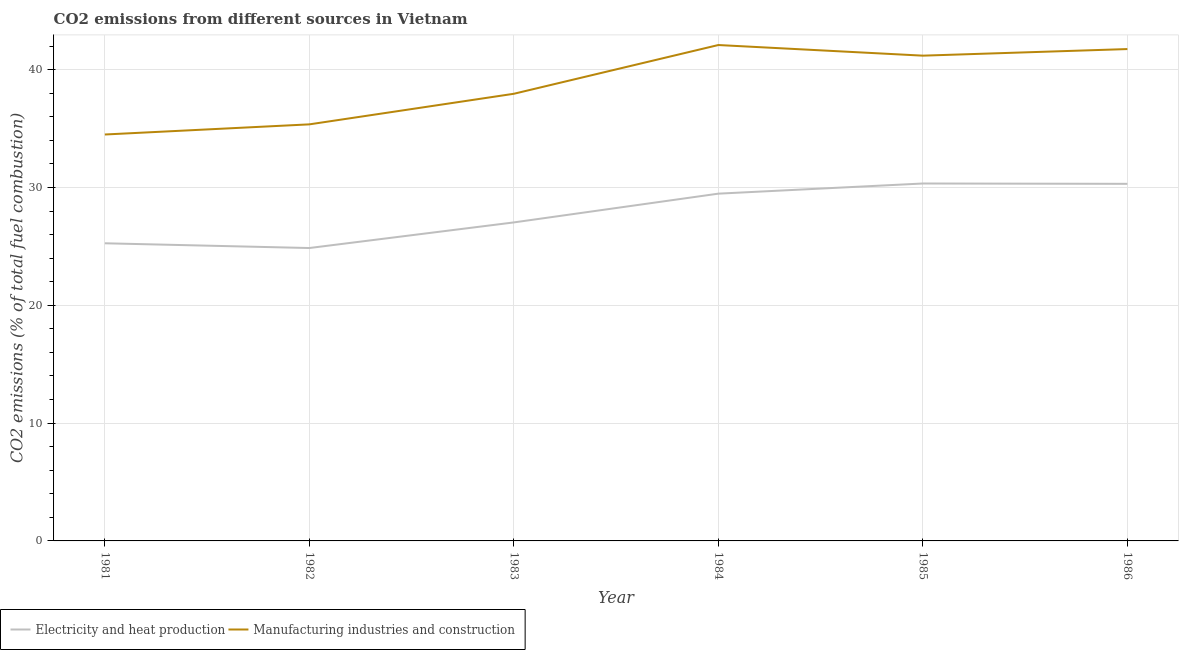How many different coloured lines are there?
Keep it short and to the point. 2. Does the line corresponding to co2 emissions due to manufacturing industries intersect with the line corresponding to co2 emissions due to electricity and heat production?
Keep it short and to the point. No. Is the number of lines equal to the number of legend labels?
Make the answer very short. Yes. What is the co2 emissions due to electricity and heat production in 1985?
Offer a very short reply. 30.34. Across all years, what is the maximum co2 emissions due to electricity and heat production?
Give a very brief answer. 30.34. Across all years, what is the minimum co2 emissions due to manufacturing industries?
Provide a short and direct response. 34.5. In which year was the co2 emissions due to electricity and heat production minimum?
Keep it short and to the point. 1982. What is the total co2 emissions due to electricity and heat production in the graph?
Your response must be concise. 167.29. What is the difference between the co2 emissions due to manufacturing industries in 1985 and that in 1986?
Ensure brevity in your answer.  -0.56. What is the difference between the co2 emissions due to electricity and heat production in 1982 and the co2 emissions due to manufacturing industries in 1981?
Keep it short and to the point. -9.64. What is the average co2 emissions due to manufacturing industries per year?
Give a very brief answer. 38.81. In the year 1986, what is the difference between the co2 emissions due to electricity and heat production and co2 emissions due to manufacturing industries?
Provide a succinct answer. -11.44. What is the ratio of the co2 emissions due to manufacturing industries in 1982 to that in 1985?
Your response must be concise. 0.86. Is the co2 emissions due to electricity and heat production in 1983 less than that in 1986?
Make the answer very short. Yes. Is the difference between the co2 emissions due to manufacturing industries in 1982 and 1985 greater than the difference between the co2 emissions due to electricity and heat production in 1982 and 1985?
Provide a short and direct response. No. What is the difference between the highest and the second highest co2 emissions due to manufacturing industries?
Make the answer very short. 0.34. What is the difference between the highest and the lowest co2 emissions due to electricity and heat production?
Provide a succinct answer. 5.48. In how many years, is the co2 emissions due to manufacturing industries greater than the average co2 emissions due to manufacturing industries taken over all years?
Keep it short and to the point. 3. Is the sum of the co2 emissions due to electricity and heat production in 1982 and 1984 greater than the maximum co2 emissions due to manufacturing industries across all years?
Ensure brevity in your answer.  Yes. Does the co2 emissions due to electricity and heat production monotonically increase over the years?
Make the answer very short. No. How many lines are there?
Make the answer very short. 2. Are the values on the major ticks of Y-axis written in scientific E-notation?
Keep it short and to the point. No. Does the graph contain any zero values?
Offer a terse response. No. What is the title of the graph?
Keep it short and to the point. CO2 emissions from different sources in Vietnam. Does "Depositors" appear as one of the legend labels in the graph?
Make the answer very short. No. What is the label or title of the Y-axis?
Your answer should be very brief. CO2 emissions (% of total fuel combustion). What is the CO2 emissions (% of total fuel combustion) in Electricity and heat production in 1981?
Offer a terse response. 25.26. What is the CO2 emissions (% of total fuel combustion) in Manufacturing industries and construction in 1981?
Ensure brevity in your answer.  34.5. What is the CO2 emissions (% of total fuel combustion) of Electricity and heat production in 1982?
Keep it short and to the point. 24.86. What is the CO2 emissions (% of total fuel combustion) in Manufacturing industries and construction in 1982?
Keep it short and to the point. 35.36. What is the CO2 emissions (% of total fuel combustion) of Electricity and heat production in 1983?
Your answer should be very brief. 27.04. What is the CO2 emissions (% of total fuel combustion) in Manufacturing industries and construction in 1983?
Offer a very short reply. 37.95. What is the CO2 emissions (% of total fuel combustion) of Electricity and heat production in 1984?
Your answer should be compact. 29.48. What is the CO2 emissions (% of total fuel combustion) in Manufacturing industries and construction in 1984?
Your response must be concise. 42.09. What is the CO2 emissions (% of total fuel combustion) of Electricity and heat production in 1985?
Offer a very short reply. 30.34. What is the CO2 emissions (% of total fuel combustion) of Manufacturing industries and construction in 1985?
Provide a succinct answer. 41.19. What is the CO2 emissions (% of total fuel combustion) in Electricity and heat production in 1986?
Offer a very short reply. 30.31. What is the CO2 emissions (% of total fuel combustion) of Manufacturing industries and construction in 1986?
Give a very brief answer. 41.75. Across all years, what is the maximum CO2 emissions (% of total fuel combustion) in Electricity and heat production?
Your response must be concise. 30.34. Across all years, what is the maximum CO2 emissions (% of total fuel combustion) in Manufacturing industries and construction?
Give a very brief answer. 42.09. Across all years, what is the minimum CO2 emissions (% of total fuel combustion) of Electricity and heat production?
Make the answer very short. 24.86. Across all years, what is the minimum CO2 emissions (% of total fuel combustion) of Manufacturing industries and construction?
Your answer should be very brief. 34.5. What is the total CO2 emissions (% of total fuel combustion) in Electricity and heat production in the graph?
Provide a succinct answer. 167.29. What is the total CO2 emissions (% of total fuel combustion) of Manufacturing industries and construction in the graph?
Offer a very short reply. 232.85. What is the difference between the CO2 emissions (% of total fuel combustion) in Electricity and heat production in 1981 and that in 1982?
Offer a very short reply. 0.4. What is the difference between the CO2 emissions (% of total fuel combustion) in Manufacturing industries and construction in 1981 and that in 1982?
Offer a terse response. -0.86. What is the difference between the CO2 emissions (% of total fuel combustion) in Electricity and heat production in 1981 and that in 1983?
Offer a terse response. -1.77. What is the difference between the CO2 emissions (% of total fuel combustion) of Manufacturing industries and construction in 1981 and that in 1983?
Offer a terse response. -3.46. What is the difference between the CO2 emissions (% of total fuel combustion) in Electricity and heat production in 1981 and that in 1984?
Keep it short and to the point. -4.21. What is the difference between the CO2 emissions (% of total fuel combustion) of Manufacturing industries and construction in 1981 and that in 1984?
Ensure brevity in your answer.  -7.59. What is the difference between the CO2 emissions (% of total fuel combustion) of Electricity and heat production in 1981 and that in 1985?
Make the answer very short. -5.07. What is the difference between the CO2 emissions (% of total fuel combustion) of Manufacturing industries and construction in 1981 and that in 1985?
Ensure brevity in your answer.  -6.69. What is the difference between the CO2 emissions (% of total fuel combustion) in Electricity and heat production in 1981 and that in 1986?
Provide a short and direct response. -5.05. What is the difference between the CO2 emissions (% of total fuel combustion) of Manufacturing industries and construction in 1981 and that in 1986?
Your answer should be very brief. -7.25. What is the difference between the CO2 emissions (% of total fuel combustion) in Electricity and heat production in 1982 and that in 1983?
Ensure brevity in your answer.  -2.17. What is the difference between the CO2 emissions (% of total fuel combustion) of Manufacturing industries and construction in 1982 and that in 1983?
Offer a very short reply. -2.6. What is the difference between the CO2 emissions (% of total fuel combustion) of Electricity and heat production in 1982 and that in 1984?
Keep it short and to the point. -4.61. What is the difference between the CO2 emissions (% of total fuel combustion) of Manufacturing industries and construction in 1982 and that in 1984?
Keep it short and to the point. -6.73. What is the difference between the CO2 emissions (% of total fuel combustion) in Electricity and heat production in 1982 and that in 1985?
Make the answer very short. -5.48. What is the difference between the CO2 emissions (% of total fuel combustion) in Manufacturing industries and construction in 1982 and that in 1985?
Your answer should be compact. -5.83. What is the difference between the CO2 emissions (% of total fuel combustion) of Electricity and heat production in 1982 and that in 1986?
Your response must be concise. -5.45. What is the difference between the CO2 emissions (% of total fuel combustion) of Manufacturing industries and construction in 1982 and that in 1986?
Give a very brief answer. -6.39. What is the difference between the CO2 emissions (% of total fuel combustion) of Electricity and heat production in 1983 and that in 1984?
Keep it short and to the point. -2.44. What is the difference between the CO2 emissions (% of total fuel combustion) of Manufacturing industries and construction in 1983 and that in 1984?
Provide a short and direct response. -4.14. What is the difference between the CO2 emissions (% of total fuel combustion) of Electricity and heat production in 1983 and that in 1985?
Your answer should be compact. -3.3. What is the difference between the CO2 emissions (% of total fuel combustion) in Manufacturing industries and construction in 1983 and that in 1985?
Provide a short and direct response. -3.24. What is the difference between the CO2 emissions (% of total fuel combustion) of Electricity and heat production in 1983 and that in 1986?
Make the answer very short. -3.27. What is the difference between the CO2 emissions (% of total fuel combustion) in Manufacturing industries and construction in 1983 and that in 1986?
Ensure brevity in your answer.  -3.8. What is the difference between the CO2 emissions (% of total fuel combustion) in Electricity and heat production in 1984 and that in 1985?
Provide a short and direct response. -0.86. What is the difference between the CO2 emissions (% of total fuel combustion) in Manufacturing industries and construction in 1984 and that in 1985?
Offer a terse response. 0.9. What is the difference between the CO2 emissions (% of total fuel combustion) in Electricity and heat production in 1984 and that in 1986?
Keep it short and to the point. -0.83. What is the difference between the CO2 emissions (% of total fuel combustion) of Manufacturing industries and construction in 1984 and that in 1986?
Your answer should be compact. 0.34. What is the difference between the CO2 emissions (% of total fuel combustion) in Electricity and heat production in 1985 and that in 1986?
Your answer should be very brief. 0.03. What is the difference between the CO2 emissions (% of total fuel combustion) of Manufacturing industries and construction in 1985 and that in 1986?
Your response must be concise. -0.56. What is the difference between the CO2 emissions (% of total fuel combustion) in Electricity and heat production in 1981 and the CO2 emissions (% of total fuel combustion) in Manufacturing industries and construction in 1982?
Keep it short and to the point. -10.1. What is the difference between the CO2 emissions (% of total fuel combustion) of Electricity and heat production in 1981 and the CO2 emissions (% of total fuel combustion) of Manufacturing industries and construction in 1983?
Offer a very short reply. -12.69. What is the difference between the CO2 emissions (% of total fuel combustion) in Electricity and heat production in 1981 and the CO2 emissions (% of total fuel combustion) in Manufacturing industries and construction in 1984?
Provide a short and direct response. -16.83. What is the difference between the CO2 emissions (% of total fuel combustion) of Electricity and heat production in 1981 and the CO2 emissions (% of total fuel combustion) of Manufacturing industries and construction in 1985?
Keep it short and to the point. -15.93. What is the difference between the CO2 emissions (% of total fuel combustion) of Electricity and heat production in 1981 and the CO2 emissions (% of total fuel combustion) of Manufacturing industries and construction in 1986?
Offer a very short reply. -16.49. What is the difference between the CO2 emissions (% of total fuel combustion) in Electricity and heat production in 1982 and the CO2 emissions (% of total fuel combustion) in Manufacturing industries and construction in 1983?
Keep it short and to the point. -13.09. What is the difference between the CO2 emissions (% of total fuel combustion) of Electricity and heat production in 1982 and the CO2 emissions (% of total fuel combustion) of Manufacturing industries and construction in 1984?
Give a very brief answer. -17.23. What is the difference between the CO2 emissions (% of total fuel combustion) of Electricity and heat production in 1982 and the CO2 emissions (% of total fuel combustion) of Manufacturing industries and construction in 1985?
Give a very brief answer. -16.33. What is the difference between the CO2 emissions (% of total fuel combustion) of Electricity and heat production in 1982 and the CO2 emissions (% of total fuel combustion) of Manufacturing industries and construction in 1986?
Your response must be concise. -16.89. What is the difference between the CO2 emissions (% of total fuel combustion) in Electricity and heat production in 1983 and the CO2 emissions (% of total fuel combustion) in Manufacturing industries and construction in 1984?
Provide a succinct answer. -15.06. What is the difference between the CO2 emissions (% of total fuel combustion) of Electricity and heat production in 1983 and the CO2 emissions (% of total fuel combustion) of Manufacturing industries and construction in 1985?
Make the answer very short. -14.15. What is the difference between the CO2 emissions (% of total fuel combustion) of Electricity and heat production in 1983 and the CO2 emissions (% of total fuel combustion) of Manufacturing industries and construction in 1986?
Provide a succinct answer. -14.71. What is the difference between the CO2 emissions (% of total fuel combustion) of Electricity and heat production in 1984 and the CO2 emissions (% of total fuel combustion) of Manufacturing industries and construction in 1985?
Offer a terse response. -11.71. What is the difference between the CO2 emissions (% of total fuel combustion) in Electricity and heat production in 1984 and the CO2 emissions (% of total fuel combustion) in Manufacturing industries and construction in 1986?
Your response must be concise. -12.27. What is the difference between the CO2 emissions (% of total fuel combustion) of Electricity and heat production in 1985 and the CO2 emissions (% of total fuel combustion) of Manufacturing industries and construction in 1986?
Your answer should be compact. -11.41. What is the average CO2 emissions (% of total fuel combustion) in Electricity and heat production per year?
Make the answer very short. 27.88. What is the average CO2 emissions (% of total fuel combustion) in Manufacturing industries and construction per year?
Provide a succinct answer. 38.81. In the year 1981, what is the difference between the CO2 emissions (% of total fuel combustion) of Electricity and heat production and CO2 emissions (% of total fuel combustion) of Manufacturing industries and construction?
Give a very brief answer. -9.23. In the year 1982, what is the difference between the CO2 emissions (% of total fuel combustion) of Electricity and heat production and CO2 emissions (% of total fuel combustion) of Manufacturing industries and construction?
Provide a succinct answer. -10.5. In the year 1983, what is the difference between the CO2 emissions (% of total fuel combustion) of Electricity and heat production and CO2 emissions (% of total fuel combustion) of Manufacturing industries and construction?
Make the answer very short. -10.92. In the year 1984, what is the difference between the CO2 emissions (% of total fuel combustion) in Electricity and heat production and CO2 emissions (% of total fuel combustion) in Manufacturing industries and construction?
Give a very brief answer. -12.62. In the year 1985, what is the difference between the CO2 emissions (% of total fuel combustion) of Electricity and heat production and CO2 emissions (% of total fuel combustion) of Manufacturing industries and construction?
Give a very brief answer. -10.85. In the year 1986, what is the difference between the CO2 emissions (% of total fuel combustion) in Electricity and heat production and CO2 emissions (% of total fuel combustion) in Manufacturing industries and construction?
Your answer should be very brief. -11.44. What is the ratio of the CO2 emissions (% of total fuel combustion) of Electricity and heat production in 1981 to that in 1982?
Provide a short and direct response. 1.02. What is the ratio of the CO2 emissions (% of total fuel combustion) of Manufacturing industries and construction in 1981 to that in 1982?
Keep it short and to the point. 0.98. What is the ratio of the CO2 emissions (% of total fuel combustion) in Electricity and heat production in 1981 to that in 1983?
Provide a short and direct response. 0.93. What is the ratio of the CO2 emissions (% of total fuel combustion) in Manufacturing industries and construction in 1981 to that in 1983?
Make the answer very short. 0.91. What is the ratio of the CO2 emissions (% of total fuel combustion) in Electricity and heat production in 1981 to that in 1984?
Your answer should be very brief. 0.86. What is the ratio of the CO2 emissions (% of total fuel combustion) of Manufacturing industries and construction in 1981 to that in 1984?
Ensure brevity in your answer.  0.82. What is the ratio of the CO2 emissions (% of total fuel combustion) in Electricity and heat production in 1981 to that in 1985?
Your answer should be compact. 0.83. What is the ratio of the CO2 emissions (% of total fuel combustion) of Manufacturing industries and construction in 1981 to that in 1985?
Provide a short and direct response. 0.84. What is the ratio of the CO2 emissions (% of total fuel combustion) of Electricity and heat production in 1981 to that in 1986?
Offer a terse response. 0.83. What is the ratio of the CO2 emissions (% of total fuel combustion) of Manufacturing industries and construction in 1981 to that in 1986?
Your response must be concise. 0.83. What is the ratio of the CO2 emissions (% of total fuel combustion) in Electricity and heat production in 1982 to that in 1983?
Your response must be concise. 0.92. What is the ratio of the CO2 emissions (% of total fuel combustion) of Manufacturing industries and construction in 1982 to that in 1983?
Your response must be concise. 0.93. What is the ratio of the CO2 emissions (% of total fuel combustion) of Electricity and heat production in 1982 to that in 1984?
Your answer should be compact. 0.84. What is the ratio of the CO2 emissions (% of total fuel combustion) of Manufacturing industries and construction in 1982 to that in 1984?
Keep it short and to the point. 0.84. What is the ratio of the CO2 emissions (% of total fuel combustion) in Electricity and heat production in 1982 to that in 1985?
Give a very brief answer. 0.82. What is the ratio of the CO2 emissions (% of total fuel combustion) of Manufacturing industries and construction in 1982 to that in 1985?
Keep it short and to the point. 0.86. What is the ratio of the CO2 emissions (% of total fuel combustion) of Electricity and heat production in 1982 to that in 1986?
Your answer should be very brief. 0.82. What is the ratio of the CO2 emissions (% of total fuel combustion) in Manufacturing industries and construction in 1982 to that in 1986?
Provide a succinct answer. 0.85. What is the ratio of the CO2 emissions (% of total fuel combustion) in Electricity and heat production in 1983 to that in 1984?
Keep it short and to the point. 0.92. What is the ratio of the CO2 emissions (% of total fuel combustion) in Manufacturing industries and construction in 1983 to that in 1984?
Provide a succinct answer. 0.9. What is the ratio of the CO2 emissions (% of total fuel combustion) of Electricity and heat production in 1983 to that in 1985?
Ensure brevity in your answer.  0.89. What is the ratio of the CO2 emissions (% of total fuel combustion) in Manufacturing industries and construction in 1983 to that in 1985?
Offer a very short reply. 0.92. What is the ratio of the CO2 emissions (% of total fuel combustion) of Electricity and heat production in 1983 to that in 1986?
Give a very brief answer. 0.89. What is the ratio of the CO2 emissions (% of total fuel combustion) of Manufacturing industries and construction in 1983 to that in 1986?
Offer a terse response. 0.91. What is the ratio of the CO2 emissions (% of total fuel combustion) of Electricity and heat production in 1984 to that in 1985?
Ensure brevity in your answer.  0.97. What is the ratio of the CO2 emissions (% of total fuel combustion) in Manufacturing industries and construction in 1984 to that in 1985?
Provide a succinct answer. 1.02. What is the ratio of the CO2 emissions (% of total fuel combustion) in Electricity and heat production in 1984 to that in 1986?
Provide a succinct answer. 0.97. What is the ratio of the CO2 emissions (% of total fuel combustion) in Manufacturing industries and construction in 1984 to that in 1986?
Ensure brevity in your answer.  1.01. What is the ratio of the CO2 emissions (% of total fuel combustion) in Manufacturing industries and construction in 1985 to that in 1986?
Your response must be concise. 0.99. What is the difference between the highest and the second highest CO2 emissions (% of total fuel combustion) in Electricity and heat production?
Give a very brief answer. 0.03. What is the difference between the highest and the second highest CO2 emissions (% of total fuel combustion) in Manufacturing industries and construction?
Offer a terse response. 0.34. What is the difference between the highest and the lowest CO2 emissions (% of total fuel combustion) of Electricity and heat production?
Offer a terse response. 5.48. What is the difference between the highest and the lowest CO2 emissions (% of total fuel combustion) of Manufacturing industries and construction?
Provide a short and direct response. 7.59. 